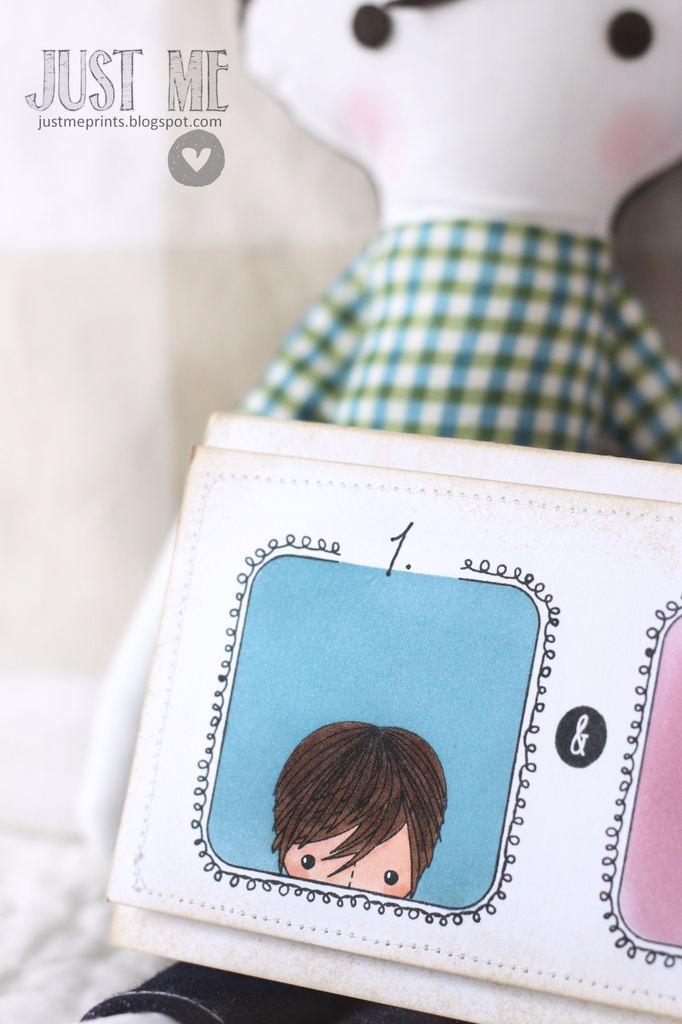What is the main subject of the image? The main subject of the image is white color things with cartoon drawings. Can you describe the appearance of these items? They have cartoon drawings on them. What else can be seen in the image? There is a toy behind the white color things. Is there any text or logo visible in the image? Yes, there is a watermark in the top left corner of the image. Can you tell me how many dogs are present in the image? There are no dogs present in the image. What method is used to sort the white color things in the image? The image does not show any sorting method being used for the white color things. 